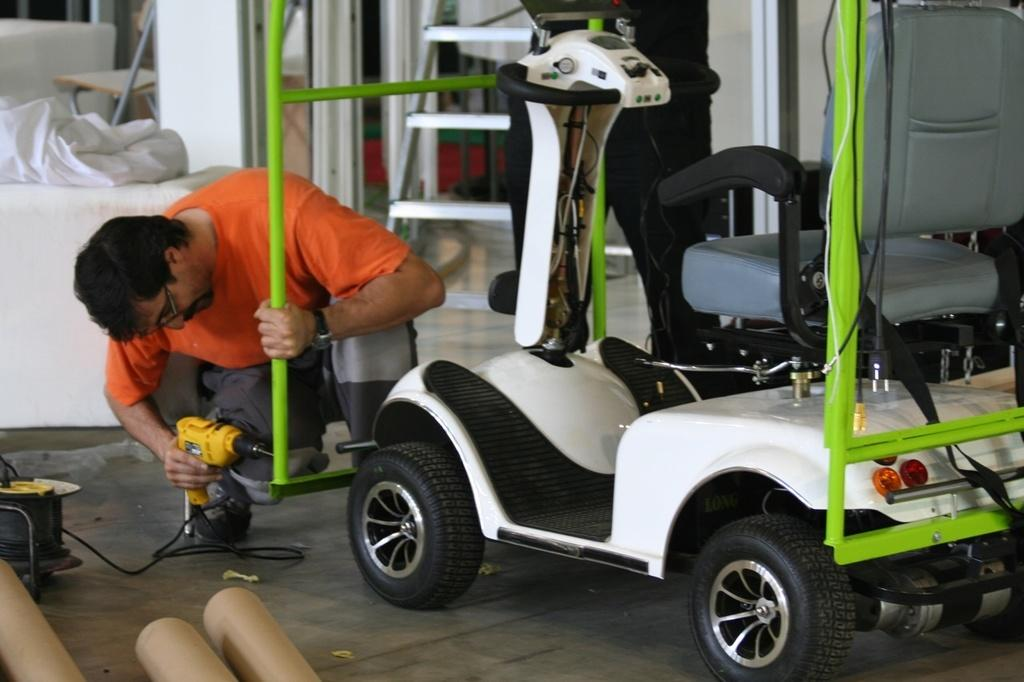What type of vehicle is in the image? There is a transit vehicle in the image. Where is the transit vehicle located in the image? The transit vehicle is on the right side of the image. What is the man in the image doing? The man is repairing the transit vehicle. Where is the man located in the image? The man is on the left side of the image. What type of wood is the man using to repair the transit vehicle in the image? There is no wood present in the image; the man is repairing the transit vehicle without using any wood. 